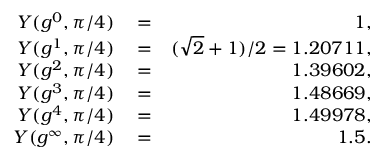Convert formula to latex. <formula><loc_0><loc_0><loc_500><loc_500>\begin{array} { r l r } { Y ( g ^ { 0 } , \pi / 4 ) } & = } & { 1 , } \\ { Y ( g ^ { 1 } , \pi / 4 ) } & = } & { ( \sqrt { 2 } + 1 ) / 2 = 1 . 2 0 7 1 1 , } \\ { Y ( g ^ { 2 } , \pi / 4 ) } & = } & { 1 . 3 9 6 0 2 , } \\ { Y ( g ^ { 3 } , \pi / 4 ) } & = } & { 1 . 4 8 6 6 9 , } \\ { Y ( g ^ { 4 } , \pi / 4 ) } & = } & { 1 . 4 9 9 7 8 , } \\ { Y ( g ^ { \infty } , \pi / 4 ) } & = } & { 1 . 5 . } \end{array}</formula> 